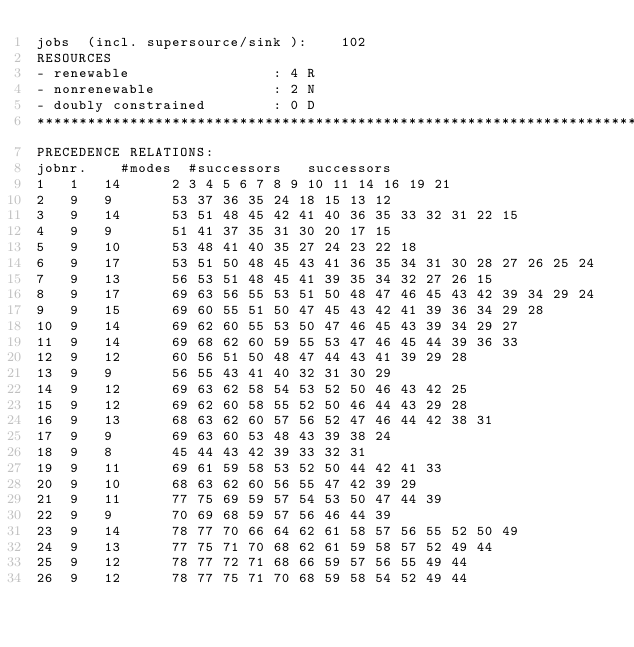<code> <loc_0><loc_0><loc_500><loc_500><_ObjectiveC_>jobs  (incl. supersource/sink ):	102
RESOURCES
- renewable                 : 4 R
- nonrenewable              : 2 N
- doubly constrained        : 0 D
************************************************************************
PRECEDENCE RELATIONS:
jobnr.    #modes  #successors   successors
1	1	14		2 3 4 5 6 7 8 9 10 11 14 16 19 21 
2	9	9		53 37 36 35 24 18 15 13 12 
3	9	14		53 51 48 45 42 41 40 36 35 33 32 31 22 15 
4	9	9		51 41 37 35 31 30 20 17 15 
5	9	10		53 48 41 40 35 27 24 23 22 18 
6	9	17		53 51 50 48 45 43 41 36 35 34 31 30 28 27 26 25 24 
7	9	13		56 53 51 48 45 41 39 35 34 32 27 26 15 
8	9	17		69 63 56 55 53 51 50 48 47 46 45 43 42 39 34 29 24 
9	9	15		69 60 55 51 50 47 45 43 42 41 39 36 34 29 28 
10	9	14		69 62 60 55 53 50 47 46 45 43 39 34 29 27 
11	9	14		69 68 62 60 59 55 53 47 46 45 44 39 36 33 
12	9	12		60 56 51 50 48 47 44 43 41 39 29 28 
13	9	9		56 55 43 41 40 32 31 30 29 
14	9	12		69 63 62 58 54 53 52 50 46 43 42 25 
15	9	12		69 62 60 58 55 52 50 46 44 43 29 28 
16	9	13		68 63 62 60 57 56 52 47 46 44 42 38 31 
17	9	9		69 63 60 53 48 43 39 38 24 
18	9	8		45 44 43 42 39 33 32 31 
19	9	11		69 61 59 58 53 52 50 44 42 41 33 
20	9	10		68 63 62 60 56 55 47 42 39 29 
21	9	11		77 75 69 59 57 54 53 50 47 44 39 
22	9	9		70 69 68 59 57 56 46 44 39 
23	9	14		78 77 70 66 64 62 61 58 57 56 55 52 50 49 
24	9	13		77 75 71 70 68 62 61 59 58 57 52 49 44 
25	9	12		78 77 72 71 68 66 59 57 56 55 49 44 
26	9	12		78 77 75 71 70 68 59 58 54 52 49 44 </code> 